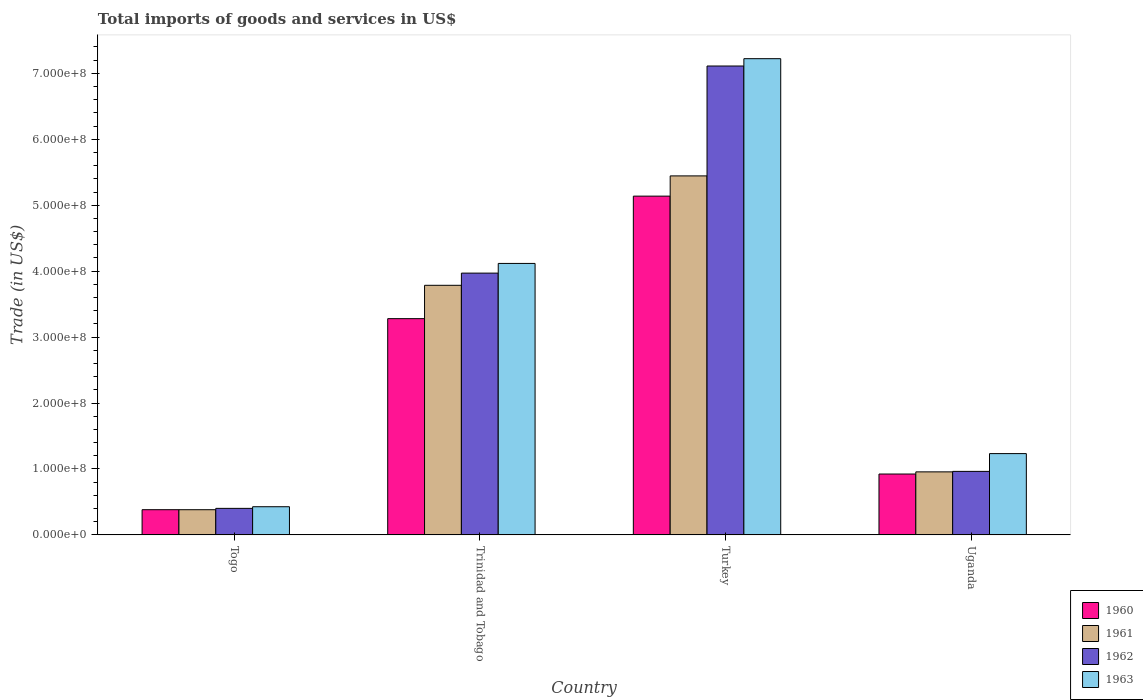How many different coloured bars are there?
Your response must be concise. 4. How many groups of bars are there?
Provide a short and direct response. 4. Are the number of bars per tick equal to the number of legend labels?
Give a very brief answer. Yes. Are the number of bars on each tick of the X-axis equal?
Provide a succinct answer. Yes. What is the label of the 2nd group of bars from the left?
Make the answer very short. Trinidad and Tobago. In how many cases, is the number of bars for a given country not equal to the number of legend labels?
Keep it short and to the point. 0. What is the total imports of goods and services in 1963 in Trinidad and Tobago?
Your response must be concise. 4.12e+08. Across all countries, what is the maximum total imports of goods and services in 1962?
Provide a succinct answer. 7.11e+08. Across all countries, what is the minimum total imports of goods and services in 1963?
Ensure brevity in your answer.  4.27e+07. In which country was the total imports of goods and services in 1961 maximum?
Offer a very short reply. Turkey. In which country was the total imports of goods and services in 1963 minimum?
Your answer should be compact. Togo. What is the total total imports of goods and services in 1960 in the graph?
Make the answer very short. 9.72e+08. What is the difference between the total imports of goods and services in 1962 in Togo and that in Trinidad and Tobago?
Your answer should be very brief. -3.57e+08. What is the difference between the total imports of goods and services in 1961 in Turkey and the total imports of goods and services in 1963 in Uganda?
Offer a terse response. 4.21e+08. What is the average total imports of goods and services in 1960 per country?
Offer a very short reply. 2.43e+08. What is the difference between the total imports of goods and services of/in 1962 and total imports of goods and services of/in 1963 in Turkey?
Your answer should be compact. -1.11e+07. What is the ratio of the total imports of goods and services in 1963 in Togo to that in Turkey?
Your answer should be very brief. 0.06. Is the total imports of goods and services in 1963 in Togo less than that in Uganda?
Provide a short and direct response. Yes. Is the difference between the total imports of goods and services in 1962 in Turkey and Uganda greater than the difference between the total imports of goods and services in 1963 in Turkey and Uganda?
Your response must be concise. Yes. What is the difference between the highest and the second highest total imports of goods and services in 1963?
Offer a terse response. 2.88e+08. What is the difference between the highest and the lowest total imports of goods and services in 1963?
Your response must be concise. 6.80e+08. What does the 2nd bar from the left in Uganda represents?
Offer a very short reply. 1961. Is it the case that in every country, the sum of the total imports of goods and services in 1963 and total imports of goods and services in 1962 is greater than the total imports of goods and services in 1961?
Keep it short and to the point. Yes. Are all the bars in the graph horizontal?
Ensure brevity in your answer.  No. How many countries are there in the graph?
Your response must be concise. 4. Are the values on the major ticks of Y-axis written in scientific E-notation?
Offer a terse response. Yes. Where does the legend appear in the graph?
Offer a terse response. Bottom right. How many legend labels are there?
Ensure brevity in your answer.  4. What is the title of the graph?
Provide a succinct answer. Total imports of goods and services in US$. Does "1978" appear as one of the legend labels in the graph?
Provide a succinct answer. No. What is the label or title of the X-axis?
Provide a succinct answer. Country. What is the label or title of the Y-axis?
Offer a terse response. Trade (in US$). What is the Trade (in US$) in 1960 in Togo?
Offer a terse response. 3.82e+07. What is the Trade (in US$) in 1961 in Togo?
Offer a terse response. 3.82e+07. What is the Trade (in US$) of 1962 in Togo?
Provide a succinct answer. 4.02e+07. What is the Trade (in US$) of 1963 in Togo?
Provide a succinct answer. 4.27e+07. What is the Trade (in US$) in 1960 in Trinidad and Tobago?
Your response must be concise. 3.28e+08. What is the Trade (in US$) in 1961 in Trinidad and Tobago?
Keep it short and to the point. 3.79e+08. What is the Trade (in US$) of 1962 in Trinidad and Tobago?
Provide a short and direct response. 3.97e+08. What is the Trade (in US$) in 1963 in Trinidad and Tobago?
Your response must be concise. 4.12e+08. What is the Trade (in US$) of 1960 in Turkey?
Ensure brevity in your answer.  5.14e+08. What is the Trade (in US$) of 1961 in Turkey?
Make the answer very short. 5.44e+08. What is the Trade (in US$) of 1962 in Turkey?
Offer a terse response. 7.11e+08. What is the Trade (in US$) of 1963 in Turkey?
Give a very brief answer. 7.22e+08. What is the Trade (in US$) in 1960 in Uganda?
Provide a succinct answer. 9.23e+07. What is the Trade (in US$) of 1961 in Uganda?
Offer a terse response. 9.56e+07. What is the Trade (in US$) in 1962 in Uganda?
Offer a very short reply. 9.63e+07. What is the Trade (in US$) in 1963 in Uganda?
Your response must be concise. 1.23e+08. Across all countries, what is the maximum Trade (in US$) in 1960?
Ensure brevity in your answer.  5.14e+08. Across all countries, what is the maximum Trade (in US$) in 1961?
Provide a succinct answer. 5.44e+08. Across all countries, what is the maximum Trade (in US$) of 1962?
Give a very brief answer. 7.11e+08. Across all countries, what is the maximum Trade (in US$) in 1963?
Provide a succinct answer. 7.22e+08. Across all countries, what is the minimum Trade (in US$) in 1960?
Keep it short and to the point. 3.82e+07. Across all countries, what is the minimum Trade (in US$) in 1961?
Provide a short and direct response. 3.82e+07. Across all countries, what is the minimum Trade (in US$) in 1962?
Give a very brief answer. 4.02e+07. Across all countries, what is the minimum Trade (in US$) of 1963?
Your answer should be very brief. 4.27e+07. What is the total Trade (in US$) of 1960 in the graph?
Keep it short and to the point. 9.72e+08. What is the total Trade (in US$) of 1961 in the graph?
Offer a terse response. 1.06e+09. What is the total Trade (in US$) in 1962 in the graph?
Provide a short and direct response. 1.24e+09. What is the total Trade (in US$) in 1963 in the graph?
Provide a short and direct response. 1.30e+09. What is the difference between the Trade (in US$) of 1960 in Togo and that in Trinidad and Tobago?
Your answer should be compact. -2.90e+08. What is the difference between the Trade (in US$) of 1961 in Togo and that in Trinidad and Tobago?
Give a very brief answer. -3.40e+08. What is the difference between the Trade (in US$) of 1962 in Togo and that in Trinidad and Tobago?
Offer a terse response. -3.57e+08. What is the difference between the Trade (in US$) of 1963 in Togo and that in Trinidad and Tobago?
Make the answer very short. -3.69e+08. What is the difference between the Trade (in US$) in 1960 in Togo and that in Turkey?
Your response must be concise. -4.76e+08. What is the difference between the Trade (in US$) in 1961 in Togo and that in Turkey?
Provide a short and direct response. -5.06e+08. What is the difference between the Trade (in US$) in 1962 in Togo and that in Turkey?
Provide a short and direct response. -6.71e+08. What is the difference between the Trade (in US$) in 1963 in Togo and that in Turkey?
Ensure brevity in your answer.  -6.80e+08. What is the difference between the Trade (in US$) in 1960 in Togo and that in Uganda?
Provide a succinct answer. -5.41e+07. What is the difference between the Trade (in US$) in 1961 in Togo and that in Uganda?
Your answer should be very brief. -5.74e+07. What is the difference between the Trade (in US$) of 1962 in Togo and that in Uganda?
Make the answer very short. -5.61e+07. What is the difference between the Trade (in US$) in 1963 in Togo and that in Uganda?
Ensure brevity in your answer.  -8.06e+07. What is the difference between the Trade (in US$) in 1960 in Trinidad and Tobago and that in Turkey?
Provide a succinct answer. -1.86e+08. What is the difference between the Trade (in US$) of 1961 in Trinidad and Tobago and that in Turkey?
Your response must be concise. -1.66e+08. What is the difference between the Trade (in US$) of 1962 in Trinidad and Tobago and that in Turkey?
Ensure brevity in your answer.  -3.14e+08. What is the difference between the Trade (in US$) in 1963 in Trinidad and Tobago and that in Turkey?
Your response must be concise. -3.11e+08. What is the difference between the Trade (in US$) of 1960 in Trinidad and Tobago and that in Uganda?
Provide a short and direct response. 2.36e+08. What is the difference between the Trade (in US$) of 1961 in Trinidad and Tobago and that in Uganda?
Offer a very short reply. 2.83e+08. What is the difference between the Trade (in US$) of 1962 in Trinidad and Tobago and that in Uganda?
Ensure brevity in your answer.  3.01e+08. What is the difference between the Trade (in US$) in 1963 in Trinidad and Tobago and that in Uganda?
Your answer should be compact. 2.88e+08. What is the difference between the Trade (in US$) in 1960 in Turkey and that in Uganda?
Ensure brevity in your answer.  4.21e+08. What is the difference between the Trade (in US$) of 1961 in Turkey and that in Uganda?
Make the answer very short. 4.49e+08. What is the difference between the Trade (in US$) of 1962 in Turkey and that in Uganda?
Your answer should be compact. 6.15e+08. What is the difference between the Trade (in US$) in 1963 in Turkey and that in Uganda?
Offer a very short reply. 5.99e+08. What is the difference between the Trade (in US$) in 1960 in Togo and the Trade (in US$) in 1961 in Trinidad and Tobago?
Make the answer very short. -3.40e+08. What is the difference between the Trade (in US$) in 1960 in Togo and the Trade (in US$) in 1962 in Trinidad and Tobago?
Offer a terse response. -3.59e+08. What is the difference between the Trade (in US$) in 1960 in Togo and the Trade (in US$) in 1963 in Trinidad and Tobago?
Provide a succinct answer. -3.74e+08. What is the difference between the Trade (in US$) of 1961 in Togo and the Trade (in US$) of 1962 in Trinidad and Tobago?
Offer a terse response. -3.59e+08. What is the difference between the Trade (in US$) in 1961 in Togo and the Trade (in US$) in 1963 in Trinidad and Tobago?
Offer a very short reply. -3.74e+08. What is the difference between the Trade (in US$) of 1962 in Togo and the Trade (in US$) of 1963 in Trinidad and Tobago?
Offer a very short reply. -3.71e+08. What is the difference between the Trade (in US$) of 1960 in Togo and the Trade (in US$) of 1961 in Turkey?
Your answer should be compact. -5.06e+08. What is the difference between the Trade (in US$) in 1960 in Togo and the Trade (in US$) in 1962 in Turkey?
Your response must be concise. -6.73e+08. What is the difference between the Trade (in US$) in 1960 in Togo and the Trade (in US$) in 1963 in Turkey?
Keep it short and to the point. -6.84e+08. What is the difference between the Trade (in US$) in 1961 in Togo and the Trade (in US$) in 1962 in Turkey?
Offer a very short reply. -6.73e+08. What is the difference between the Trade (in US$) of 1961 in Togo and the Trade (in US$) of 1963 in Turkey?
Your answer should be compact. -6.84e+08. What is the difference between the Trade (in US$) in 1962 in Togo and the Trade (in US$) in 1963 in Turkey?
Offer a terse response. -6.82e+08. What is the difference between the Trade (in US$) of 1960 in Togo and the Trade (in US$) of 1961 in Uganda?
Provide a succinct answer. -5.74e+07. What is the difference between the Trade (in US$) of 1960 in Togo and the Trade (in US$) of 1962 in Uganda?
Provide a succinct answer. -5.81e+07. What is the difference between the Trade (in US$) of 1960 in Togo and the Trade (in US$) of 1963 in Uganda?
Keep it short and to the point. -8.51e+07. What is the difference between the Trade (in US$) of 1961 in Togo and the Trade (in US$) of 1962 in Uganda?
Your answer should be compact. -5.81e+07. What is the difference between the Trade (in US$) in 1961 in Togo and the Trade (in US$) in 1963 in Uganda?
Provide a succinct answer. -8.51e+07. What is the difference between the Trade (in US$) in 1962 in Togo and the Trade (in US$) in 1963 in Uganda?
Your answer should be very brief. -8.31e+07. What is the difference between the Trade (in US$) in 1960 in Trinidad and Tobago and the Trade (in US$) in 1961 in Turkey?
Ensure brevity in your answer.  -2.16e+08. What is the difference between the Trade (in US$) in 1960 in Trinidad and Tobago and the Trade (in US$) in 1962 in Turkey?
Provide a succinct answer. -3.83e+08. What is the difference between the Trade (in US$) of 1960 in Trinidad and Tobago and the Trade (in US$) of 1963 in Turkey?
Offer a terse response. -3.94e+08. What is the difference between the Trade (in US$) of 1961 in Trinidad and Tobago and the Trade (in US$) of 1962 in Turkey?
Provide a short and direct response. -3.33e+08. What is the difference between the Trade (in US$) of 1961 in Trinidad and Tobago and the Trade (in US$) of 1963 in Turkey?
Keep it short and to the point. -3.44e+08. What is the difference between the Trade (in US$) in 1962 in Trinidad and Tobago and the Trade (in US$) in 1963 in Turkey?
Make the answer very short. -3.25e+08. What is the difference between the Trade (in US$) in 1960 in Trinidad and Tobago and the Trade (in US$) in 1961 in Uganda?
Make the answer very short. 2.32e+08. What is the difference between the Trade (in US$) of 1960 in Trinidad and Tobago and the Trade (in US$) of 1962 in Uganda?
Ensure brevity in your answer.  2.32e+08. What is the difference between the Trade (in US$) in 1960 in Trinidad and Tobago and the Trade (in US$) in 1963 in Uganda?
Provide a succinct answer. 2.05e+08. What is the difference between the Trade (in US$) in 1961 in Trinidad and Tobago and the Trade (in US$) in 1962 in Uganda?
Your response must be concise. 2.82e+08. What is the difference between the Trade (in US$) of 1961 in Trinidad and Tobago and the Trade (in US$) of 1963 in Uganda?
Ensure brevity in your answer.  2.55e+08. What is the difference between the Trade (in US$) in 1962 in Trinidad and Tobago and the Trade (in US$) in 1963 in Uganda?
Provide a short and direct response. 2.74e+08. What is the difference between the Trade (in US$) of 1960 in Turkey and the Trade (in US$) of 1961 in Uganda?
Make the answer very short. 4.18e+08. What is the difference between the Trade (in US$) in 1960 in Turkey and the Trade (in US$) in 1962 in Uganda?
Make the answer very short. 4.17e+08. What is the difference between the Trade (in US$) in 1960 in Turkey and the Trade (in US$) in 1963 in Uganda?
Give a very brief answer. 3.90e+08. What is the difference between the Trade (in US$) of 1961 in Turkey and the Trade (in US$) of 1962 in Uganda?
Provide a short and direct response. 4.48e+08. What is the difference between the Trade (in US$) in 1961 in Turkey and the Trade (in US$) in 1963 in Uganda?
Give a very brief answer. 4.21e+08. What is the difference between the Trade (in US$) of 1962 in Turkey and the Trade (in US$) of 1963 in Uganda?
Make the answer very short. 5.88e+08. What is the average Trade (in US$) of 1960 per country?
Your answer should be compact. 2.43e+08. What is the average Trade (in US$) of 1961 per country?
Make the answer very short. 2.64e+08. What is the average Trade (in US$) in 1962 per country?
Offer a terse response. 3.11e+08. What is the average Trade (in US$) of 1963 per country?
Provide a succinct answer. 3.25e+08. What is the difference between the Trade (in US$) in 1960 and Trade (in US$) in 1961 in Togo?
Keep it short and to the point. 1.01e+04. What is the difference between the Trade (in US$) in 1960 and Trade (in US$) in 1962 in Togo?
Your response must be concise. -2.01e+06. What is the difference between the Trade (in US$) in 1960 and Trade (in US$) in 1963 in Togo?
Offer a terse response. -4.50e+06. What is the difference between the Trade (in US$) of 1961 and Trade (in US$) of 1962 in Togo?
Offer a very short reply. -2.03e+06. What is the difference between the Trade (in US$) in 1961 and Trade (in US$) in 1963 in Togo?
Offer a terse response. -4.51e+06. What is the difference between the Trade (in US$) in 1962 and Trade (in US$) in 1963 in Togo?
Ensure brevity in your answer.  -2.48e+06. What is the difference between the Trade (in US$) in 1960 and Trade (in US$) in 1961 in Trinidad and Tobago?
Your answer should be very brief. -5.06e+07. What is the difference between the Trade (in US$) in 1960 and Trade (in US$) in 1962 in Trinidad and Tobago?
Offer a terse response. -6.91e+07. What is the difference between the Trade (in US$) in 1960 and Trade (in US$) in 1963 in Trinidad and Tobago?
Ensure brevity in your answer.  -8.38e+07. What is the difference between the Trade (in US$) of 1961 and Trade (in US$) of 1962 in Trinidad and Tobago?
Provide a succinct answer. -1.85e+07. What is the difference between the Trade (in US$) of 1961 and Trade (in US$) of 1963 in Trinidad and Tobago?
Ensure brevity in your answer.  -3.32e+07. What is the difference between the Trade (in US$) of 1962 and Trade (in US$) of 1963 in Trinidad and Tobago?
Offer a terse response. -1.47e+07. What is the difference between the Trade (in US$) of 1960 and Trade (in US$) of 1961 in Turkey?
Your answer should be very brief. -3.07e+07. What is the difference between the Trade (in US$) in 1960 and Trade (in US$) in 1962 in Turkey?
Offer a very short reply. -1.97e+08. What is the difference between the Trade (in US$) in 1960 and Trade (in US$) in 1963 in Turkey?
Make the answer very short. -2.08e+08. What is the difference between the Trade (in US$) of 1961 and Trade (in US$) of 1962 in Turkey?
Ensure brevity in your answer.  -1.67e+08. What is the difference between the Trade (in US$) in 1961 and Trade (in US$) in 1963 in Turkey?
Your answer should be very brief. -1.78e+08. What is the difference between the Trade (in US$) in 1962 and Trade (in US$) in 1963 in Turkey?
Your response must be concise. -1.11e+07. What is the difference between the Trade (in US$) in 1960 and Trade (in US$) in 1961 in Uganda?
Your answer should be very brief. -3.28e+06. What is the difference between the Trade (in US$) in 1960 and Trade (in US$) in 1962 in Uganda?
Your response must be concise. -4.02e+06. What is the difference between the Trade (in US$) in 1960 and Trade (in US$) in 1963 in Uganda?
Provide a short and direct response. -3.10e+07. What is the difference between the Trade (in US$) in 1961 and Trade (in US$) in 1962 in Uganda?
Offer a terse response. -7.40e+05. What is the difference between the Trade (in US$) of 1961 and Trade (in US$) of 1963 in Uganda?
Offer a very short reply. -2.77e+07. What is the difference between the Trade (in US$) of 1962 and Trade (in US$) of 1963 in Uganda?
Provide a short and direct response. -2.70e+07. What is the ratio of the Trade (in US$) in 1960 in Togo to that in Trinidad and Tobago?
Your answer should be very brief. 0.12. What is the ratio of the Trade (in US$) in 1961 in Togo to that in Trinidad and Tobago?
Provide a succinct answer. 0.1. What is the ratio of the Trade (in US$) of 1962 in Togo to that in Trinidad and Tobago?
Provide a short and direct response. 0.1. What is the ratio of the Trade (in US$) of 1963 in Togo to that in Trinidad and Tobago?
Provide a short and direct response. 0.1. What is the ratio of the Trade (in US$) in 1960 in Togo to that in Turkey?
Your answer should be compact. 0.07. What is the ratio of the Trade (in US$) in 1961 in Togo to that in Turkey?
Offer a terse response. 0.07. What is the ratio of the Trade (in US$) in 1962 in Togo to that in Turkey?
Ensure brevity in your answer.  0.06. What is the ratio of the Trade (in US$) of 1963 in Togo to that in Turkey?
Your response must be concise. 0.06. What is the ratio of the Trade (in US$) in 1960 in Togo to that in Uganda?
Keep it short and to the point. 0.41. What is the ratio of the Trade (in US$) of 1961 in Togo to that in Uganda?
Give a very brief answer. 0.4. What is the ratio of the Trade (in US$) of 1962 in Togo to that in Uganda?
Your answer should be compact. 0.42. What is the ratio of the Trade (in US$) in 1963 in Togo to that in Uganda?
Your response must be concise. 0.35. What is the ratio of the Trade (in US$) of 1960 in Trinidad and Tobago to that in Turkey?
Make the answer very short. 0.64. What is the ratio of the Trade (in US$) of 1961 in Trinidad and Tobago to that in Turkey?
Offer a terse response. 0.7. What is the ratio of the Trade (in US$) of 1962 in Trinidad and Tobago to that in Turkey?
Provide a succinct answer. 0.56. What is the ratio of the Trade (in US$) of 1963 in Trinidad and Tobago to that in Turkey?
Provide a short and direct response. 0.57. What is the ratio of the Trade (in US$) of 1960 in Trinidad and Tobago to that in Uganda?
Provide a succinct answer. 3.55. What is the ratio of the Trade (in US$) of 1961 in Trinidad and Tobago to that in Uganda?
Offer a very short reply. 3.96. What is the ratio of the Trade (in US$) of 1962 in Trinidad and Tobago to that in Uganda?
Your answer should be very brief. 4.12. What is the ratio of the Trade (in US$) of 1963 in Trinidad and Tobago to that in Uganda?
Your answer should be very brief. 3.34. What is the ratio of the Trade (in US$) in 1960 in Turkey to that in Uganda?
Keep it short and to the point. 5.57. What is the ratio of the Trade (in US$) of 1961 in Turkey to that in Uganda?
Provide a short and direct response. 5.7. What is the ratio of the Trade (in US$) in 1962 in Turkey to that in Uganda?
Offer a terse response. 7.38. What is the ratio of the Trade (in US$) in 1963 in Turkey to that in Uganda?
Your answer should be compact. 5.86. What is the difference between the highest and the second highest Trade (in US$) of 1960?
Ensure brevity in your answer.  1.86e+08. What is the difference between the highest and the second highest Trade (in US$) in 1961?
Ensure brevity in your answer.  1.66e+08. What is the difference between the highest and the second highest Trade (in US$) in 1962?
Ensure brevity in your answer.  3.14e+08. What is the difference between the highest and the second highest Trade (in US$) in 1963?
Your answer should be compact. 3.11e+08. What is the difference between the highest and the lowest Trade (in US$) in 1960?
Your answer should be compact. 4.76e+08. What is the difference between the highest and the lowest Trade (in US$) in 1961?
Your answer should be compact. 5.06e+08. What is the difference between the highest and the lowest Trade (in US$) in 1962?
Provide a short and direct response. 6.71e+08. What is the difference between the highest and the lowest Trade (in US$) of 1963?
Ensure brevity in your answer.  6.80e+08. 